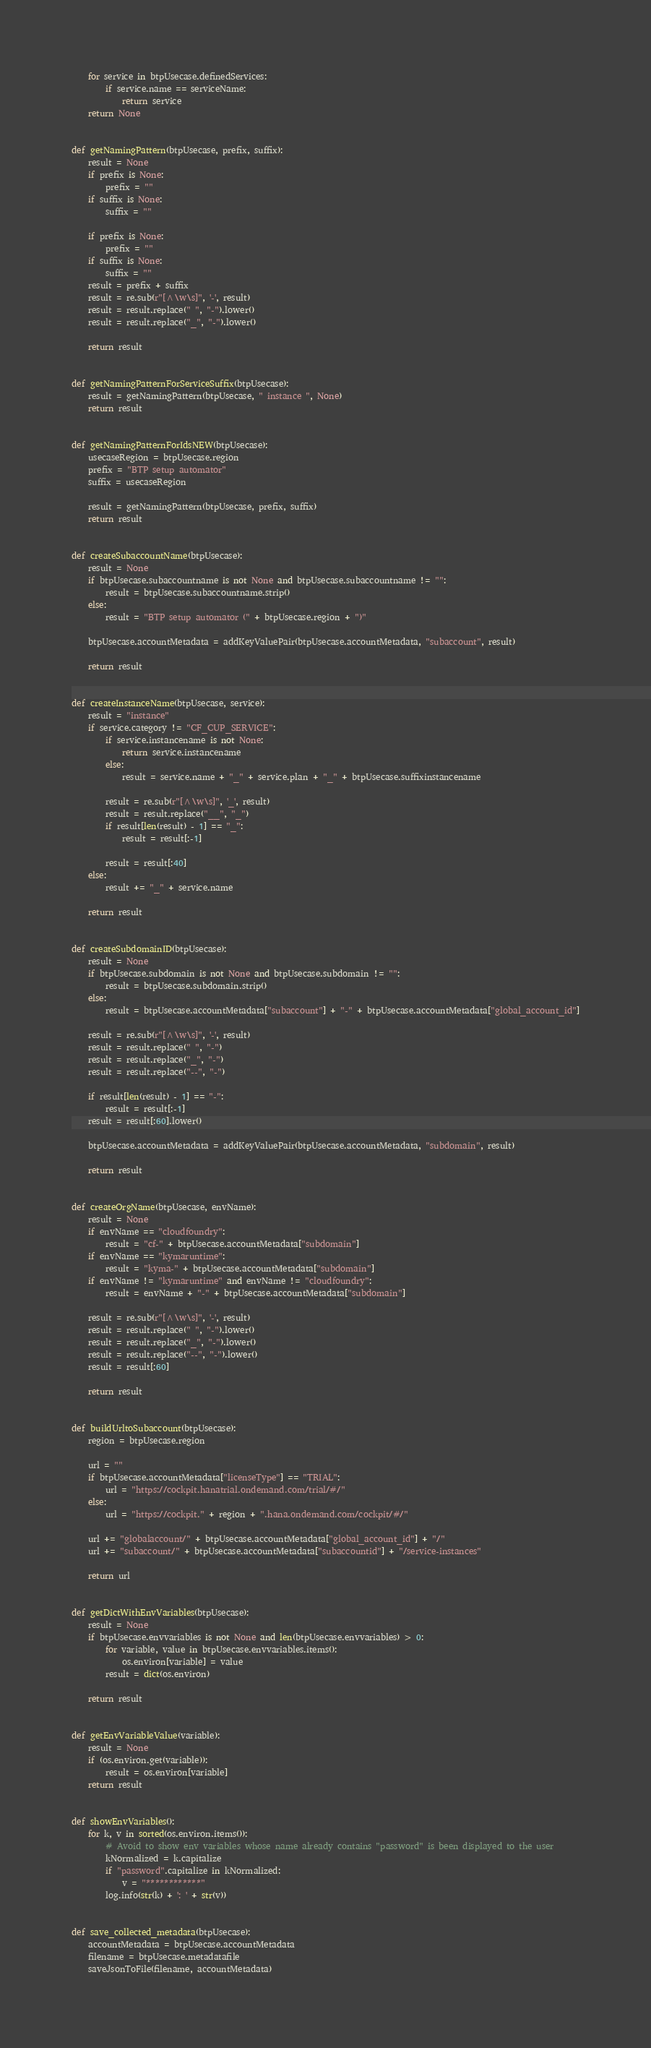<code> <loc_0><loc_0><loc_500><loc_500><_Python_>    for service in btpUsecase.definedServices:
        if service.name == serviceName:
            return service
    return None


def getNamingPattern(btpUsecase, prefix, suffix):
    result = None
    if prefix is None:
        prefix = ""
    if suffix is None:
        suffix = ""

    if prefix is None:
        prefix = ""
    if suffix is None:
        suffix = ""
    result = prefix + suffix
    result = re.sub(r"[^\w\s]", '-', result)
    result = result.replace(" ", "-").lower()
    result = result.replace("_", "-").lower()

    return result


def getNamingPatternForServiceSuffix(btpUsecase):
    result = getNamingPattern(btpUsecase, " instance ", None)
    return result


def getNamingPatternForIdsNEW(btpUsecase):
    usecaseRegion = btpUsecase.region
    prefix = "BTP setup automator"
    suffix = usecaseRegion

    result = getNamingPattern(btpUsecase, prefix, suffix)
    return result


def createSubaccountName(btpUsecase):
    result = None
    if btpUsecase.subaccountname is not None and btpUsecase.subaccountname != "":
        result = btpUsecase.subaccountname.strip()
    else:
        result = "BTP setup automator (" + btpUsecase.region + ")"

    btpUsecase.accountMetadata = addKeyValuePair(btpUsecase.accountMetadata, "subaccount", result)

    return result


def createInstanceName(btpUsecase, service):
    result = "instance"
    if service.category != "CF_CUP_SERVICE":
        if service.instancename is not None:
            return service.instancename
        else:
            result = service.name + "_" + service.plan + "_" + btpUsecase.suffixinstancename

        result = re.sub(r"[^\w\s]", '_', result)
        result = result.replace("__", "_")
        if result[len(result) - 1] == "_":
            result = result[:-1]

        result = result[:40]
    else:
        result += "_" + service.name

    return result


def createSubdomainID(btpUsecase):
    result = None
    if btpUsecase.subdomain is not None and btpUsecase.subdomain != "":
        result = btpUsecase.subdomain.strip()
    else:
        result = btpUsecase.accountMetadata["subaccount"] + "-" + btpUsecase.accountMetadata["global_account_id"]

    result = re.sub(r"[^\w\s]", '-', result)
    result = result.replace(" ", "-")
    result = result.replace("_", "-")
    result = result.replace("--", "-")

    if result[len(result) - 1] == "-":
        result = result[:-1]
    result = result[:60].lower()

    btpUsecase.accountMetadata = addKeyValuePair(btpUsecase.accountMetadata, "subdomain", result)

    return result


def createOrgName(btpUsecase, envName):
    result = None
    if envName == "cloudfoundry":
        result = "cf-" + btpUsecase.accountMetadata["subdomain"]
    if envName == "kymaruntime":
        result = "kyma-" + btpUsecase.accountMetadata["subdomain"]
    if envName != "kymaruntime" and envName != "cloudfoundry":
        result = envName + "-" + btpUsecase.accountMetadata["subdomain"]

    result = re.sub(r"[^\w\s]", '-', result)
    result = result.replace(" ", "-").lower()
    result = result.replace("_", "-").lower()
    result = result.replace("--", "-").lower()
    result = result[:60]

    return result


def buildUrltoSubaccount(btpUsecase):
    region = btpUsecase.region

    url = ""
    if btpUsecase.accountMetadata["licenseType"] == "TRIAL":
        url = "https://cockpit.hanatrial.ondemand.com/trial/#/"
    else:
        url = "https://cockpit." + region + ".hana.ondemand.com/cockpit/#/"

    url += "globalaccount/" + btpUsecase.accountMetadata["global_account_id"] + "/"
    url += "subaccount/" + btpUsecase.accountMetadata["subaccountid"] + "/service-instances"

    return url


def getDictWithEnvVariables(btpUsecase):
    result = None
    if btpUsecase.envvariables is not None and len(btpUsecase.envvariables) > 0:
        for variable, value in btpUsecase.envvariables.items():
            os.environ[variable] = value
        result = dict(os.environ)

    return result


def getEnvVariableValue(variable):
    result = None
    if (os.environ.get(variable)):
        result = os.environ[variable]
    return result


def showEnvVariables():
    for k, v in sorted(os.environ.items()):
        # Avoid to show env variables whose name already contains "password" is been displayed to the user
        kNormalized = k.capitalize
        if "password".capitalize in kNormalized:
            v = "************"
        log.info(str(k) + ': ' + str(v))


def save_collected_metadata(btpUsecase):
    accountMetadata = btpUsecase.accountMetadata
    filename = btpUsecase.metadatafile
    saveJsonToFile(filename, accountMetadata)
</code> 